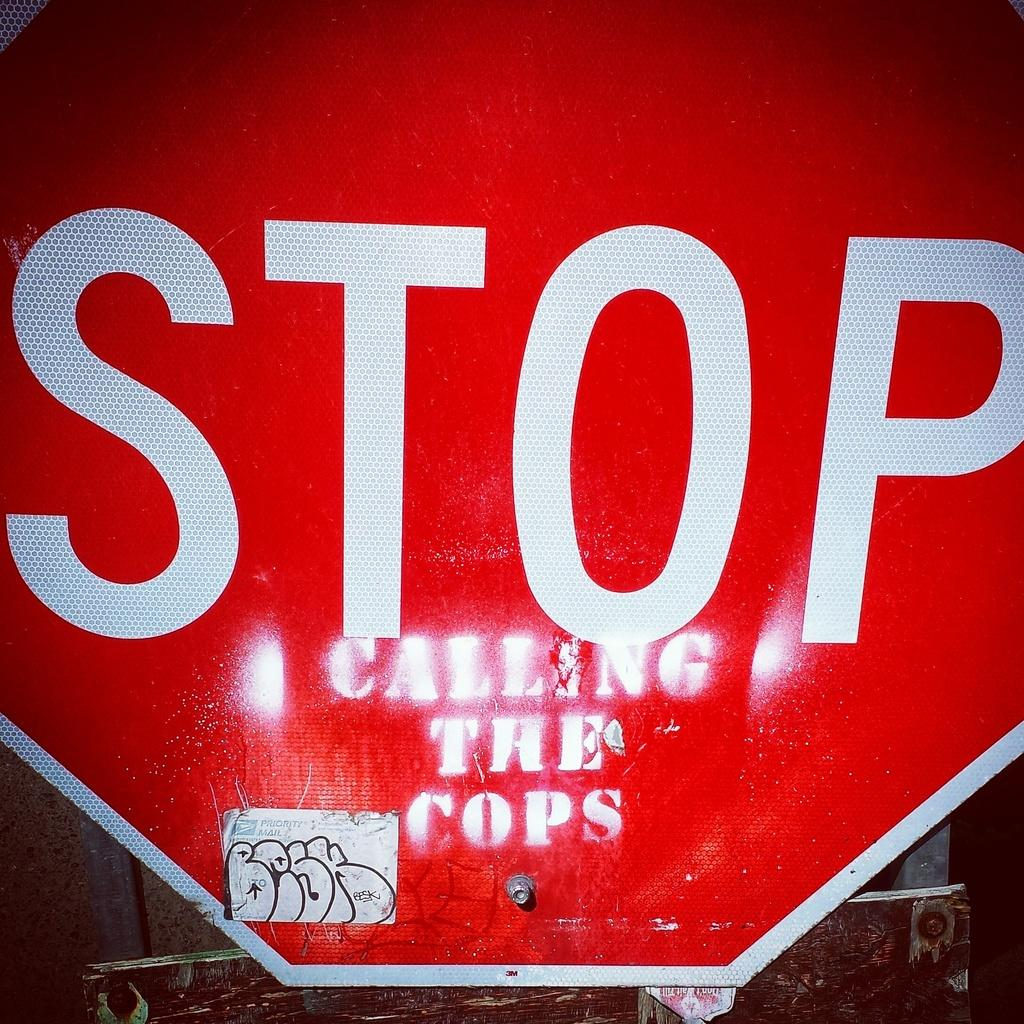Provide a one-sentence caption for the provided image. A stop sign with a grafitti message painted on it that says calling the cops. 